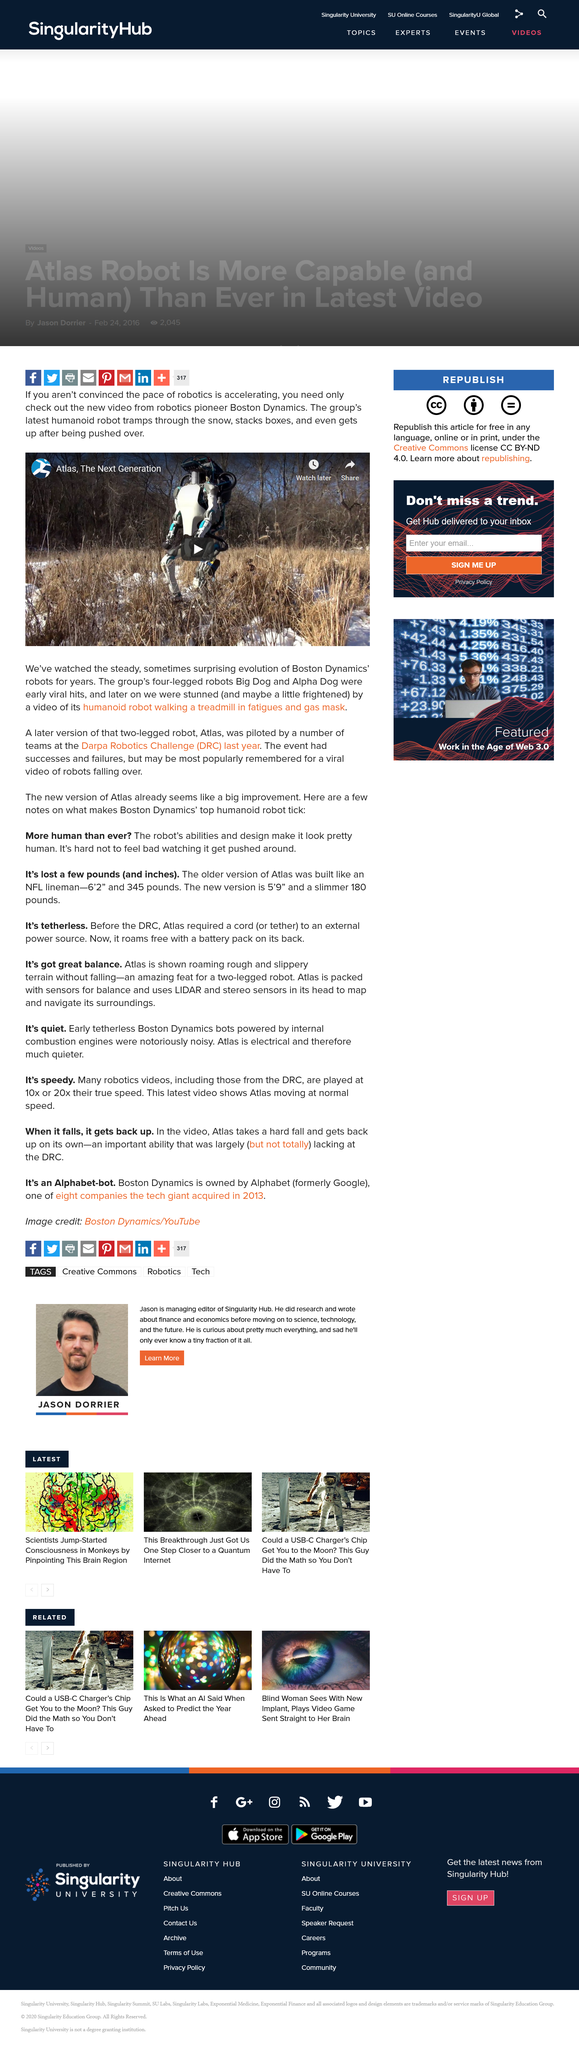Indicate a few pertinent items in this graphic. I declare that the robot "Big Dog" has four legs. Atlas," the humanoid robot developed by the Boston Dynamics company, was piloted in the "DARPA Robotics Challenge" competition last year. Boston Dynamics developed the robot Atlas. 